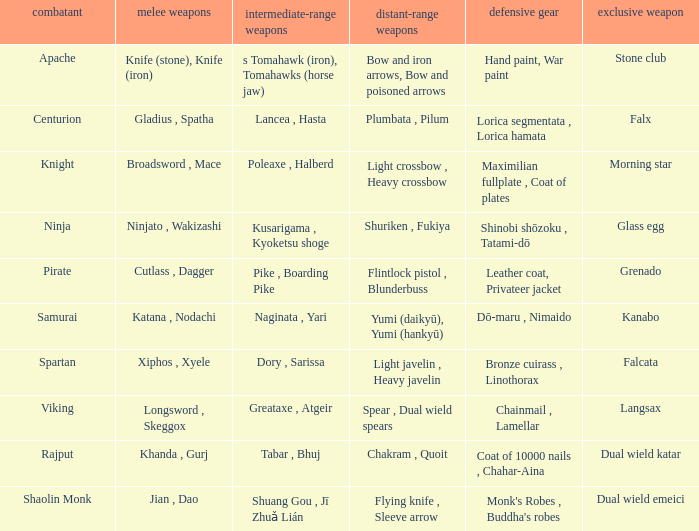If the armor is bronze cuirass , linothorax, what are the close ranged weapons? Xiphos , Xyele. 